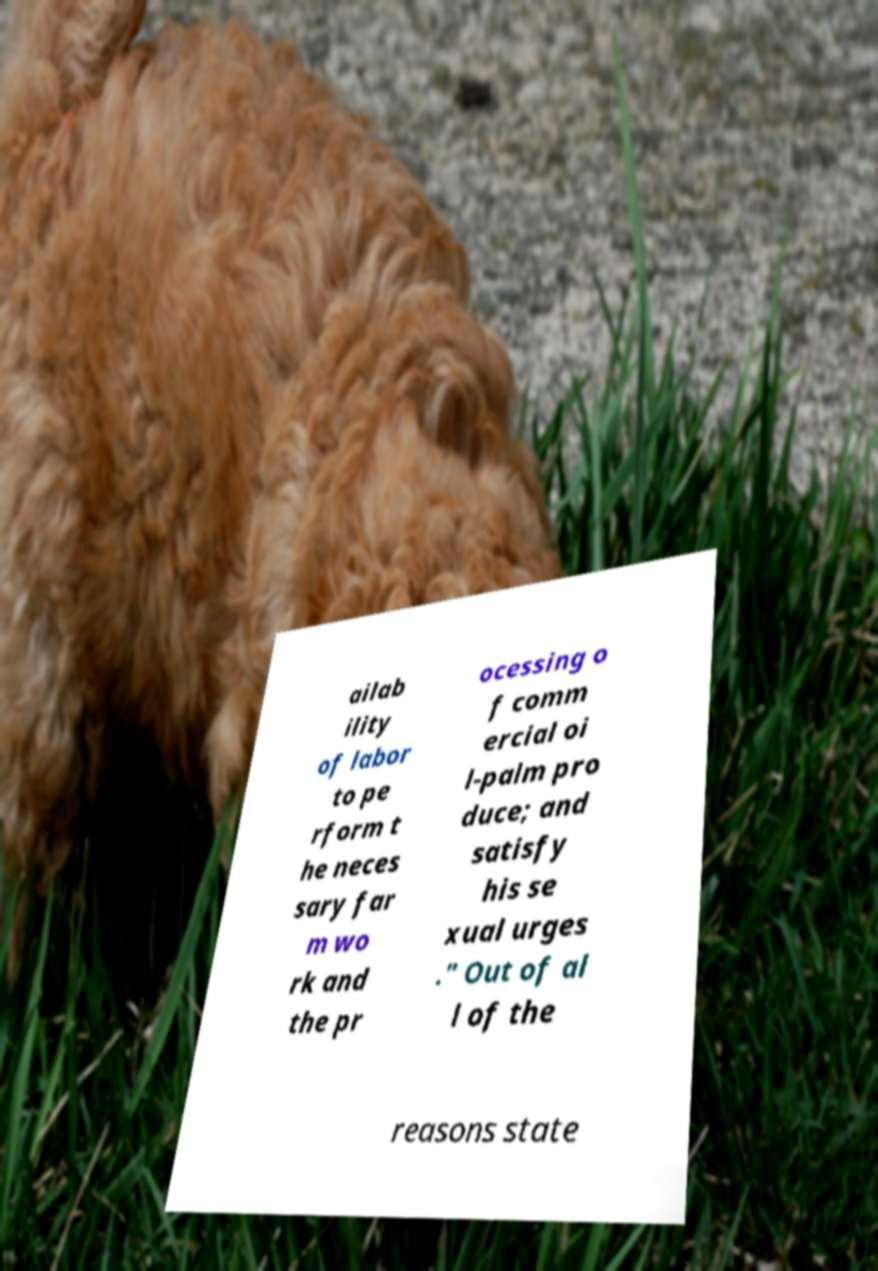I need the written content from this picture converted into text. Can you do that? ailab ility of labor to pe rform t he neces sary far m wo rk and the pr ocessing o f comm ercial oi l-palm pro duce; and satisfy his se xual urges ." Out of al l of the reasons state 